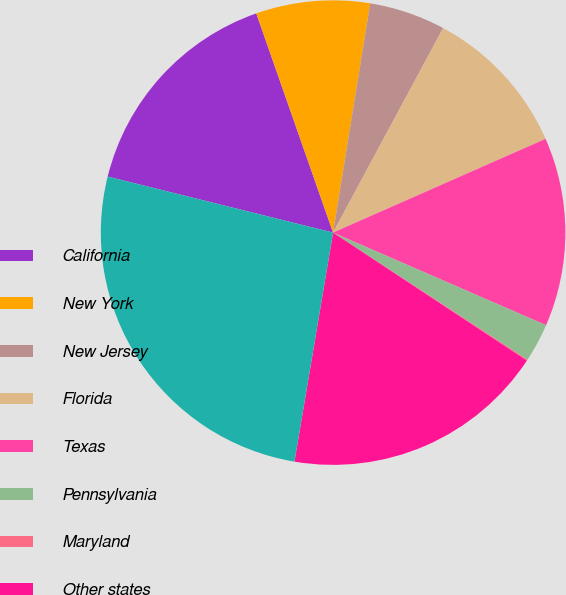Convert chart. <chart><loc_0><loc_0><loc_500><loc_500><pie_chart><fcel>California<fcel>New York<fcel>New Jersey<fcel>Florida<fcel>Texas<fcel>Pennsylvania<fcel>Maryland<fcel>Other states<fcel>Total^<nl><fcel>15.76%<fcel>7.92%<fcel>5.3%<fcel>10.53%<fcel>13.14%<fcel>2.69%<fcel>0.07%<fcel>18.37%<fcel>26.22%<nl></chart> 